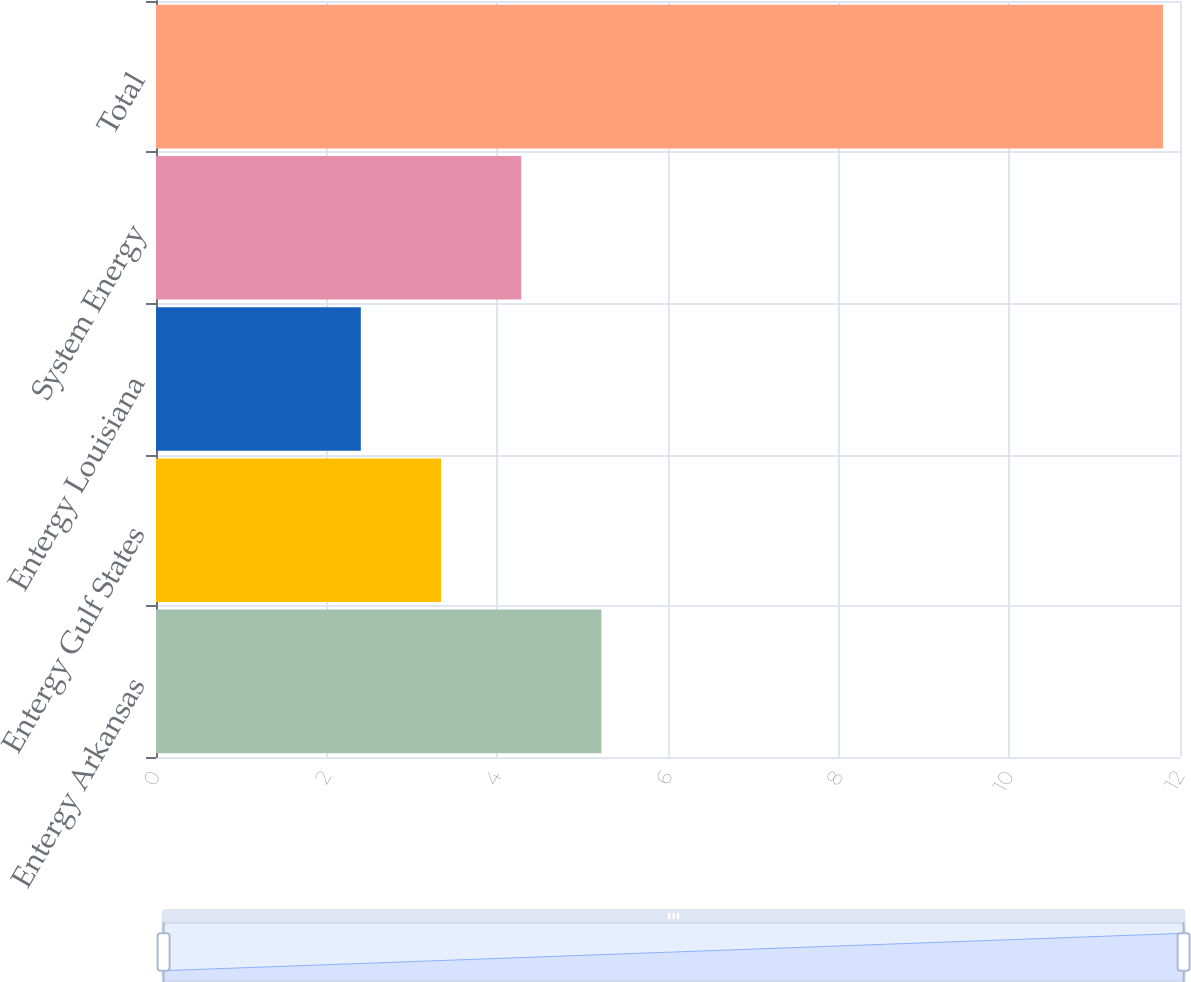<chart> <loc_0><loc_0><loc_500><loc_500><bar_chart><fcel>Entergy Arkansas<fcel>Entergy Gulf States<fcel>Entergy Louisiana<fcel>System Energy<fcel>Total<nl><fcel>5.22<fcel>3.34<fcel>2.4<fcel>4.28<fcel>11.8<nl></chart> 